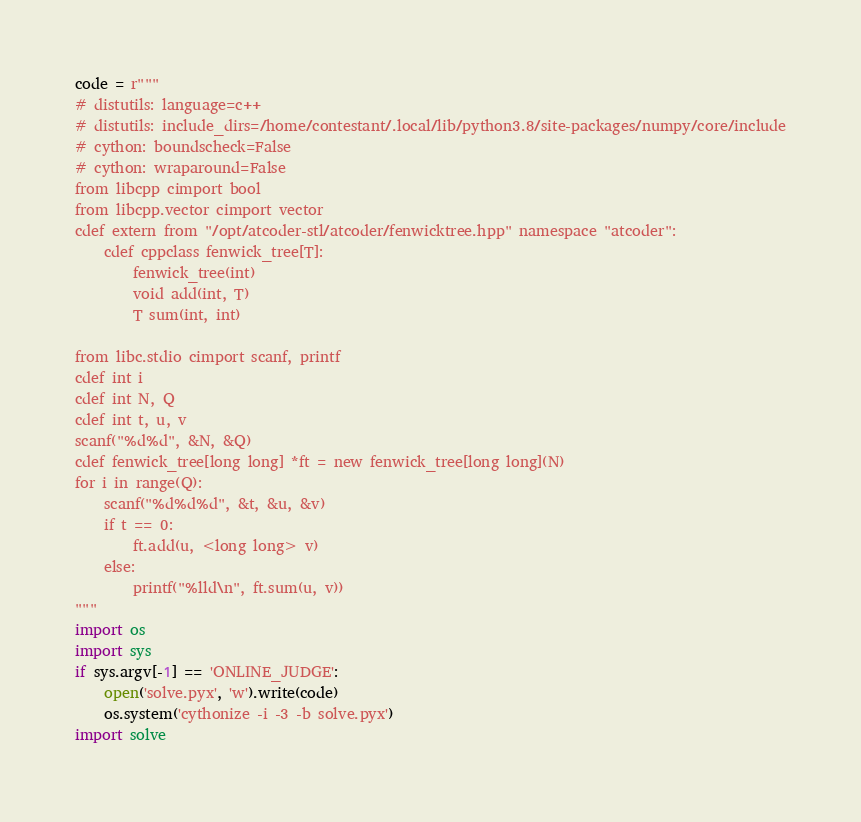<code> <loc_0><loc_0><loc_500><loc_500><_Cython_>code = r"""
# distutils: language=c++
# distutils: include_dirs=/home/contestant/.local/lib/python3.8/site-packages/numpy/core/include
# cython: boundscheck=False
# cython: wraparound=False
from libcpp cimport bool
from libcpp.vector cimport vector
cdef extern from "/opt/atcoder-stl/atcoder/fenwicktree.hpp" namespace "atcoder":
    cdef cppclass fenwick_tree[T]:
        fenwick_tree(int)
        void add(int, T)
        T sum(int, int)

from libc.stdio cimport scanf, printf
cdef int i
cdef int N, Q
cdef int t, u, v
scanf("%d%d", &N, &Q)
cdef fenwick_tree[long long] *ft = new fenwick_tree[long long](N)
for i in range(Q):
    scanf("%d%d%d", &t, &u, &v)
    if t == 0:
        ft.add(u, <long long> v)
    else:
        printf("%lld\n", ft.sum(u, v))
"""
import os
import sys
if sys.argv[-1] == 'ONLINE_JUDGE':
    open('solve.pyx', 'w').write(code)
    os.system('cythonize -i -3 -b solve.pyx')
import solve
</code> 